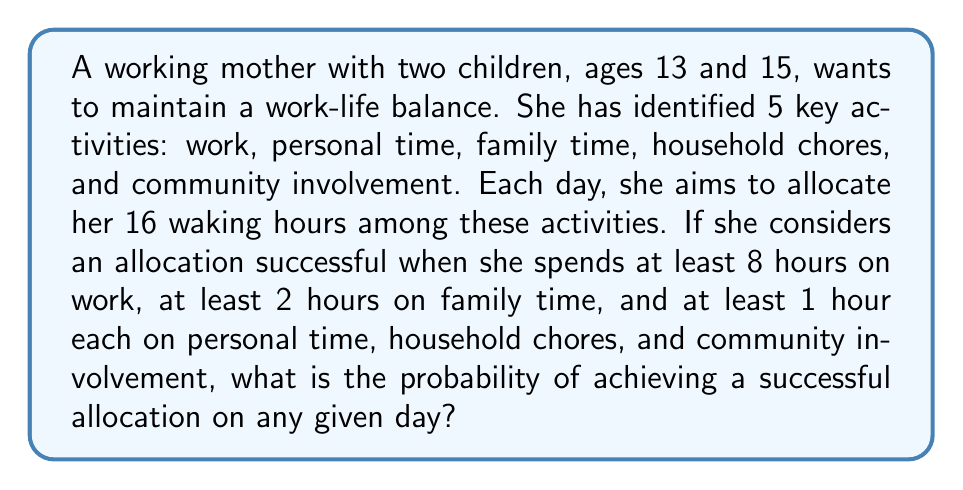Solve this math problem. Let's approach this step-by-step:

1) First, we need to define our sample space. The sample space is all possible ways to allocate 16 hours among 5 activities. This can be represented as the number of integer solutions to the equation:

   $$x_1 + x_2 + x_3 + x_4 + x_5 = 16$$

   where $x_i \geq 0$ for all $i$.

2) The number of such solutions is given by the stars and bars formula:

   $$\binom{16 + 5 - 1}{5 - 1} = \binom{20}{4} = 4845$$

3) Now, let's consider the successful allocations. We need:
   - $x_1 \geq 8$ (work)
   - $x_2 \geq 1$ (personal time)
   - $x_3 \geq 2$ (family time)
   - $x_4 \geq 1$ (household chores)
   - $x_5 \geq 1$ (community involvement)

4) If we subtract these minimum values, we're left with 3 hours to distribute:

   $$(x_1 - 8) + (x_2 - 1) + (x_3 - 2) + (x_4 - 1) + (x_5 - 1) = 3$$

5) Let $y_i = x_i - m_i$, where $m_i$ is the minimum value for each $x_i$. Then we need to find the number of solutions to:

   $$y_1 + y_2 + y_3 + y_4 + y_5 = 3$$

   where $y_i \geq 0$ for all $i$.

6) Again, using the stars and bars formula:

   $$\binom{3 + 5 - 1}{5 - 1} = \binom{7}{4} = 35$$

7) The probability is then the number of successful allocations divided by the total number of possible allocations:

   $$P(\text{successful allocation}) = \frac{35}{4845} \approx 0.00722$$
Answer: $\frac{35}{4845} \approx 0.00722$ 